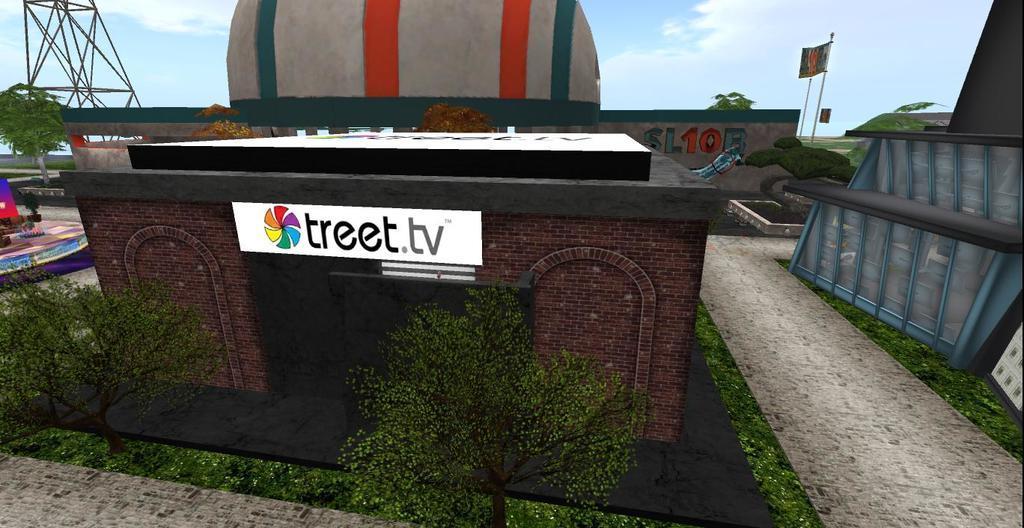Describe this image in one or two sentences. The picture is an animation. In the foreground of the picture there are trees, grass, board and building. On the right there is building. In the background there are trees, stones, hoarding and constructions. On the left there is an object. 